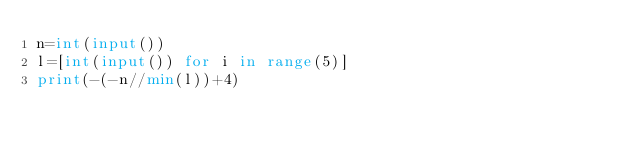Convert code to text. <code><loc_0><loc_0><loc_500><loc_500><_Python_>n=int(input())
l=[int(input()) for i in range(5)]
print(-(-n//min(l))+4)</code> 